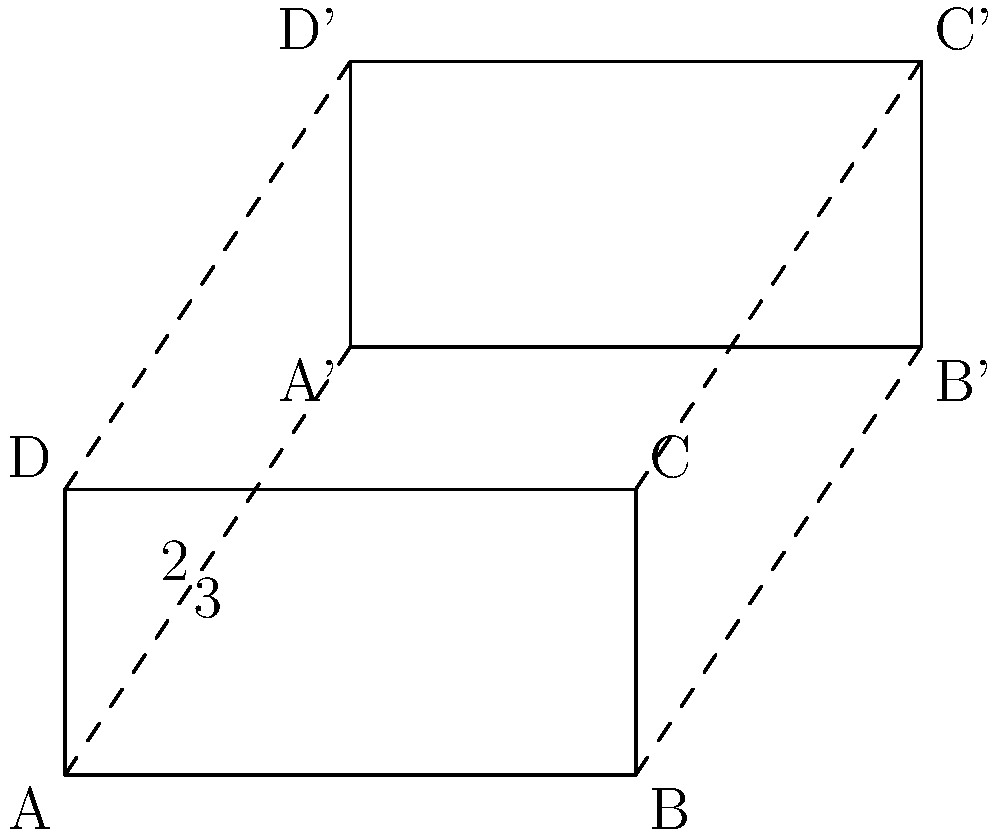In a Polish train carriage, the seating arrangement is being modified. The original rectangular seating area ABCD is translated to a new position A'B'C'D'. Given that the translation vector is (2, 3), what is the area of the new seating arrangement A'B'C'D'? To find the area of the new seating arrangement A'B'C'D', we can follow these steps:

1. Observe that translation preserves the shape and size of the original figure. This means that the area of A'B'C'D' will be the same as ABCD.

2. Calculate the dimensions of the original rectangle ABCD:
   - Width: $AB = 4$ units
   - Height: $AD = 2$ units

3. Calculate the area of the original rectangle ABCD:
   Area = width × height
   $$ \text{Area} = 4 \times 2 = 8 \text{ square units} $$

4. Since translation preserves area, the area of A'B'C'D' is also 8 square units.

Therefore, the area of the new seating arrangement A'B'C'D' is 8 square units.
Answer: 8 square units 